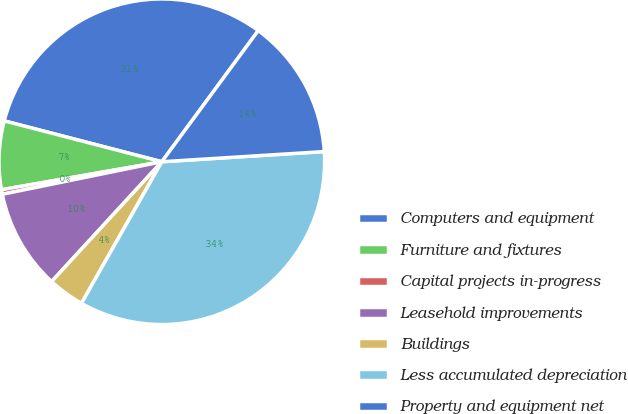<chart> <loc_0><loc_0><loc_500><loc_500><pie_chart><fcel>Computers and equipment<fcel>Furniture and fixtures<fcel>Capital projects in-progress<fcel>Leasehold improvements<fcel>Buildings<fcel>Less accumulated depreciation<fcel>Property and equipment net<nl><fcel>31.05%<fcel>6.79%<fcel>0.45%<fcel>9.96%<fcel>3.62%<fcel>34.21%<fcel>13.91%<nl></chart> 